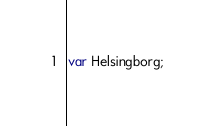Convert code to text. <code><loc_0><loc_0><loc_500><loc_500><_JavaScript_>var Helsingborg;
</code> 